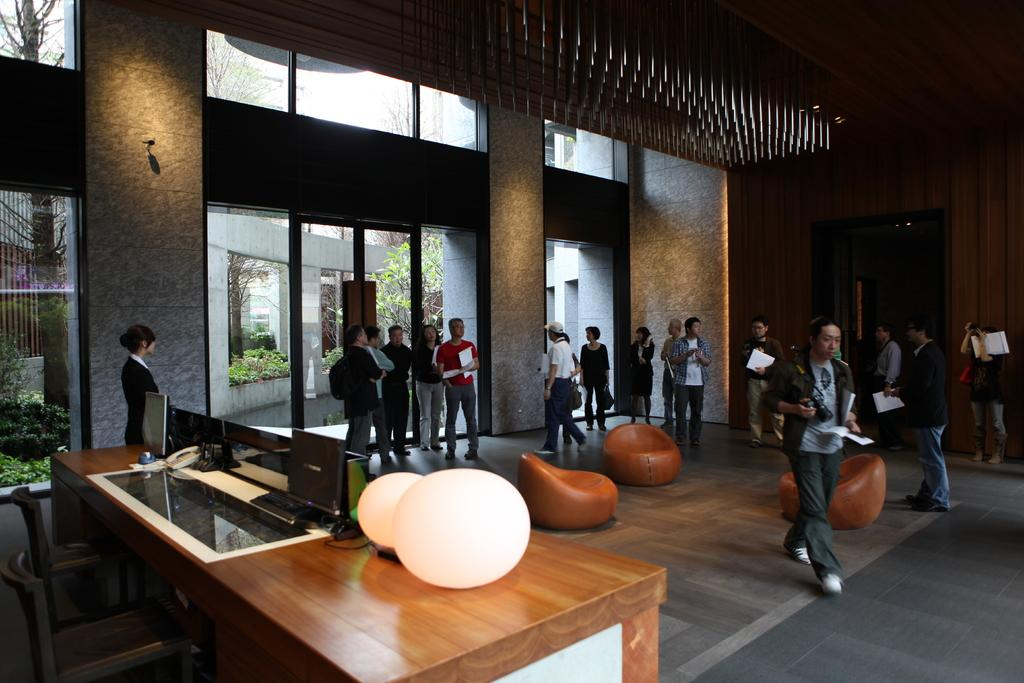What type of space is shown in the image? The image depicts a hall. Are there any people present in the hall? Yes, there are people standing in the hall. What type of seating is available in the hall? There are bean bags in the hall. What furniture is present in the hall? There is a table in the hall. What can be found on the table? There are items placed on the table. Can you see a tree growing inside the hall in the image? No, there is no tree visible inside the hall in the image. 